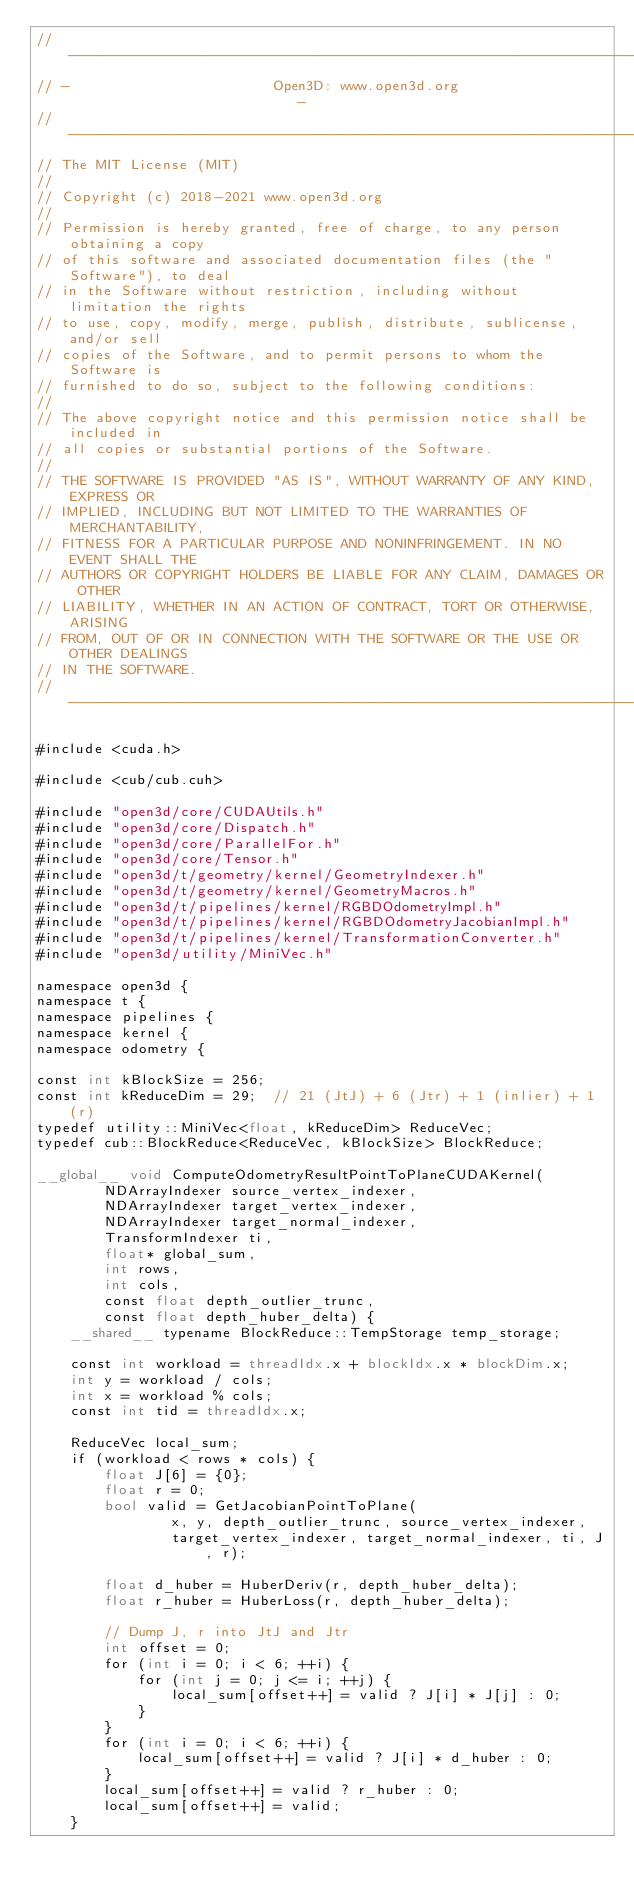<code> <loc_0><loc_0><loc_500><loc_500><_Cuda_>// ----------------------------------------------------------------------------
// -                        Open3D: www.open3d.org                            -
// ----------------------------------------------------------------------------
// The MIT License (MIT)
//
// Copyright (c) 2018-2021 www.open3d.org
//
// Permission is hereby granted, free of charge, to any person obtaining a copy
// of this software and associated documentation files (the "Software"), to deal
// in the Software without restriction, including without limitation the rights
// to use, copy, modify, merge, publish, distribute, sublicense, and/or sell
// copies of the Software, and to permit persons to whom the Software is
// furnished to do so, subject to the following conditions:
//
// The above copyright notice and this permission notice shall be included in
// all copies or substantial portions of the Software.
//
// THE SOFTWARE IS PROVIDED "AS IS", WITHOUT WARRANTY OF ANY KIND, EXPRESS OR
// IMPLIED, INCLUDING BUT NOT LIMITED TO THE WARRANTIES OF MERCHANTABILITY,
// FITNESS FOR A PARTICULAR PURPOSE AND NONINFRINGEMENT. IN NO EVENT SHALL THE
// AUTHORS OR COPYRIGHT HOLDERS BE LIABLE FOR ANY CLAIM, DAMAGES OR OTHER
// LIABILITY, WHETHER IN AN ACTION OF CONTRACT, TORT OR OTHERWISE, ARISING
// FROM, OUT OF OR IN CONNECTION WITH THE SOFTWARE OR THE USE OR OTHER DEALINGS
// IN THE SOFTWARE.
// ----------------------------------------------------------------------------

#include <cuda.h>

#include <cub/cub.cuh>

#include "open3d/core/CUDAUtils.h"
#include "open3d/core/Dispatch.h"
#include "open3d/core/ParallelFor.h"
#include "open3d/core/Tensor.h"
#include "open3d/t/geometry/kernel/GeometryIndexer.h"
#include "open3d/t/geometry/kernel/GeometryMacros.h"
#include "open3d/t/pipelines/kernel/RGBDOdometryImpl.h"
#include "open3d/t/pipelines/kernel/RGBDOdometryJacobianImpl.h"
#include "open3d/t/pipelines/kernel/TransformationConverter.h"
#include "open3d/utility/MiniVec.h"

namespace open3d {
namespace t {
namespace pipelines {
namespace kernel {
namespace odometry {

const int kBlockSize = 256;
const int kReduceDim = 29;  // 21 (JtJ) + 6 (Jtr) + 1 (inlier) + 1 (r)
typedef utility::MiniVec<float, kReduceDim> ReduceVec;
typedef cub::BlockReduce<ReduceVec, kBlockSize> BlockReduce;

__global__ void ComputeOdometryResultPointToPlaneCUDAKernel(
        NDArrayIndexer source_vertex_indexer,
        NDArrayIndexer target_vertex_indexer,
        NDArrayIndexer target_normal_indexer,
        TransformIndexer ti,
        float* global_sum,
        int rows,
        int cols,
        const float depth_outlier_trunc,
        const float depth_huber_delta) {
    __shared__ typename BlockReduce::TempStorage temp_storage;

    const int workload = threadIdx.x + blockIdx.x * blockDim.x;
    int y = workload / cols;
    int x = workload % cols;
    const int tid = threadIdx.x;

    ReduceVec local_sum;
    if (workload < rows * cols) {
        float J[6] = {0};
        float r = 0;
        bool valid = GetJacobianPointToPlane(
                x, y, depth_outlier_trunc, source_vertex_indexer,
                target_vertex_indexer, target_normal_indexer, ti, J, r);

        float d_huber = HuberDeriv(r, depth_huber_delta);
        float r_huber = HuberLoss(r, depth_huber_delta);

        // Dump J, r into JtJ and Jtr
        int offset = 0;
        for (int i = 0; i < 6; ++i) {
            for (int j = 0; j <= i; ++j) {
                local_sum[offset++] = valid ? J[i] * J[j] : 0;
            }
        }
        for (int i = 0; i < 6; ++i) {
            local_sum[offset++] = valid ? J[i] * d_huber : 0;
        }
        local_sum[offset++] = valid ? r_huber : 0;
        local_sum[offset++] = valid;
    }
</code> 